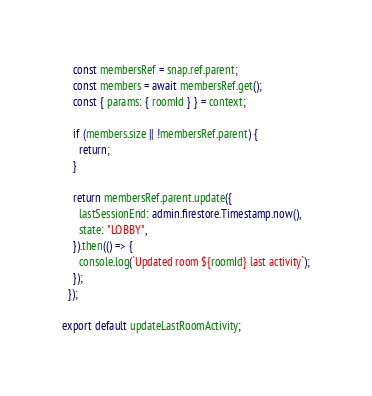<code> <loc_0><loc_0><loc_500><loc_500><_TypeScript_>    const membersRef = snap.ref.parent;
    const members = await membersRef.get();
    const { params: { roomId } } = context;

    if (members.size || !membersRef.parent) {
      return;
    }

    return membersRef.parent.update({
      lastSessionEnd: admin.firestore.Timestamp.now(),
      state: "LOBBY",
    }).then(() => {
      console.log(`Updated room ${roomId} last activity`);
    });
  });

export default updateLastRoomActivity;</code> 